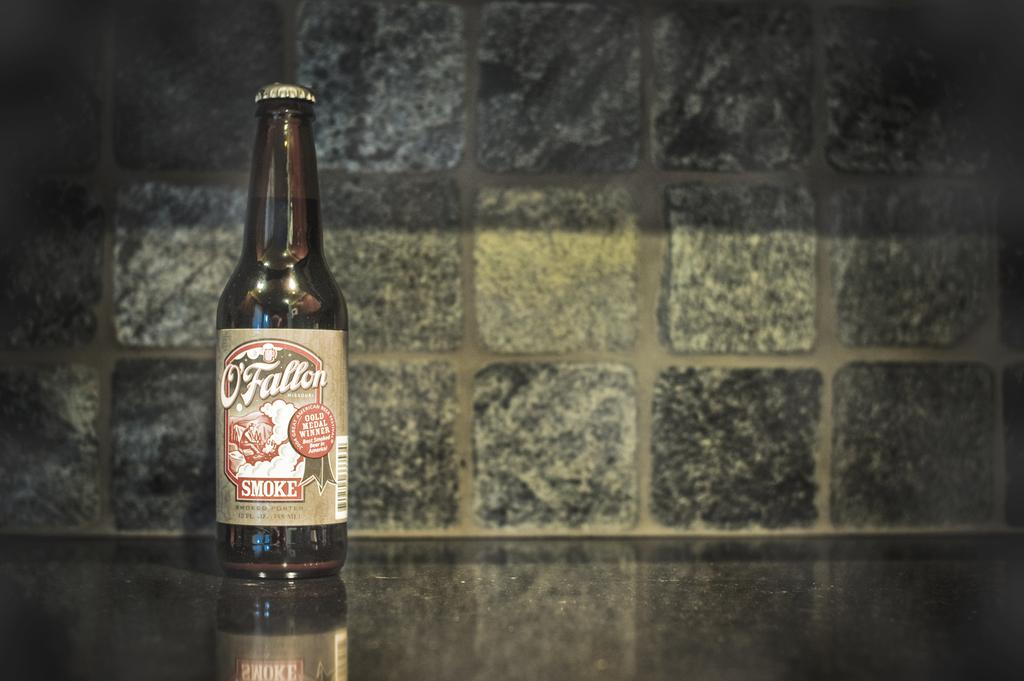<image>
Write a terse but informative summary of the picture. A bottle has the brand label O'Fallon and is advertised as a gold medal winner. 